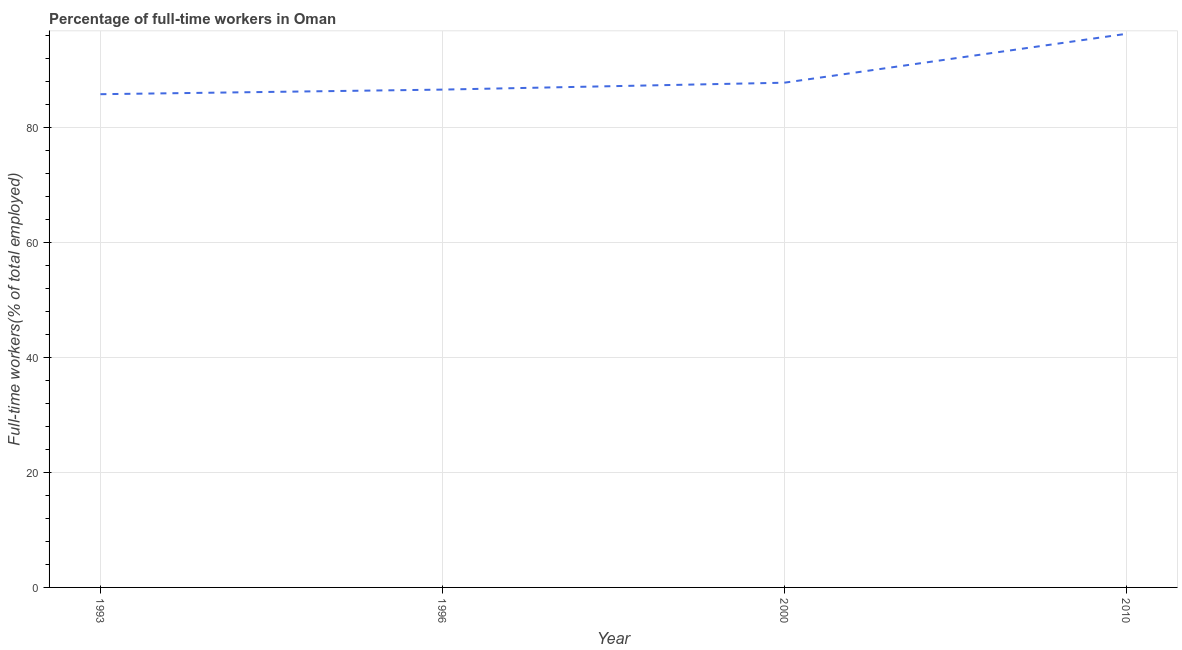What is the percentage of full-time workers in 1993?
Make the answer very short. 85.8. Across all years, what is the maximum percentage of full-time workers?
Ensure brevity in your answer.  96.3. Across all years, what is the minimum percentage of full-time workers?
Your answer should be compact. 85.8. In which year was the percentage of full-time workers maximum?
Provide a succinct answer. 2010. In which year was the percentage of full-time workers minimum?
Your response must be concise. 1993. What is the sum of the percentage of full-time workers?
Ensure brevity in your answer.  356.5. What is the difference between the percentage of full-time workers in 1996 and 2000?
Give a very brief answer. -1.2. What is the average percentage of full-time workers per year?
Give a very brief answer. 89.13. What is the median percentage of full-time workers?
Ensure brevity in your answer.  87.2. Do a majority of the years between 2010 and 2000 (inclusive) have percentage of full-time workers greater than 36 %?
Provide a short and direct response. No. What is the ratio of the percentage of full-time workers in 1996 to that in 2010?
Make the answer very short. 0.9. Is the difference between the percentage of full-time workers in 1993 and 1996 greater than the difference between any two years?
Provide a succinct answer. No. Is the sum of the percentage of full-time workers in 1993 and 2010 greater than the maximum percentage of full-time workers across all years?
Offer a terse response. Yes. What is the difference between the highest and the lowest percentage of full-time workers?
Provide a succinct answer. 10.5. In how many years, is the percentage of full-time workers greater than the average percentage of full-time workers taken over all years?
Provide a short and direct response. 1. Does the percentage of full-time workers monotonically increase over the years?
Your answer should be very brief. Yes. How many years are there in the graph?
Your response must be concise. 4. What is the difference between two consecutive major ticks on the Y-axis?
Give a very brief answer. 20. Does the graph contain any zero values?
Offer a very short reply. No. What is the title of the graph?
Ensure brevity in your answer.  Percentage of full-time workers in Oman. What is the label or title of the X-axis?
Your answer should be very brief. Year. What is the label or title of the Y-axis?
Provide a short and direct response. Full-time workers(% of total employed). What is the Full-time workers(% of total employed) of 1993?
Provide a succinct answer. 85.8. What is the Full-time workers(% of total employed) of 1996?
Provide a succinct answer. 86.6. What is the Full-time workers(% of total employed) of 2000?
Your response must be concise. 87.8. What is the Full-time workers(% of total employed) of 2010?
Keep it short and to the point. 96.3. What is the difference between the Full-time workers(% of total employed) in 1993 and 2000?
Provide a short and direct response. -2. What is the difference between the Full-time workers(% of total employed) in 2000 and 2010?
Ensure brevity in your answer.  -8.5. What is the ratio of the Full-time workers(% of total employed) in 1993 to that in 1996?
Give a very brief answer. 0.99. What is the ratio of the Full-time workers(% of total employed) in 1993 to that in 2000?
Your answer should be very brief. 0.98. What is the ratio of the Full-time workers(% of total employed) in 1993 to that in 2010?
Your response must be concise. 0.89. What is the ratio of the Full-time workers(% of total employed) in 1996 to that in 2000?
Ensure brevity in your answer.  0.99. What is the ratio of the Full-time workers(% of total employed) in 1996 to that in 2010?
Keep it short and to the point. 0.9. What is the ratio of the Full-time workers(% of total employed) in 2000 to that in 2010?
Ensure brevity in your answer.  0.91. 